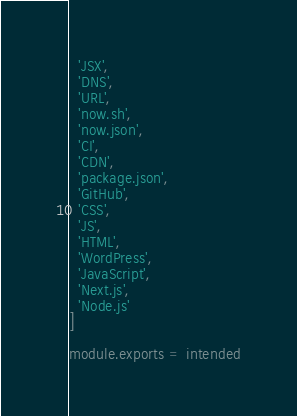<code> <loc_0><loc_0><loc_500><loc_500><_JavaScript_>  'JSX',
  'DNS',
  'URL',
  'now.sh',
  'now.json',
  'CI',
  'CDN',
  'package.json',
  'GitHub',
  'CSS',
  'JS',
  'HTML',
  'WordPress',
  'JavaScript',
  'Next.js',
  'Node.js'
]

module.exports = intended
</code> 